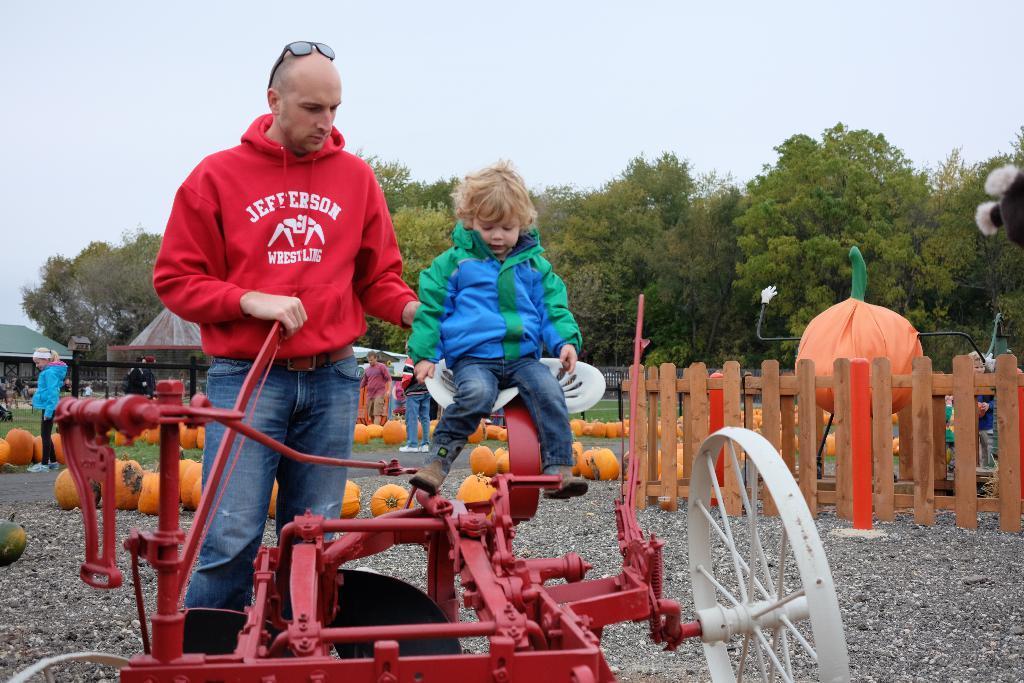Could you give a brief overview of what you see in this image? In this image I can see a person wearing red and blue colored dress is standing and a child wearing green and blue colored dress is sitting on a white and red colored object. In the background I can see few pumpkins on the ground, few persons, few sheds, the railing, few trees and the sky. 